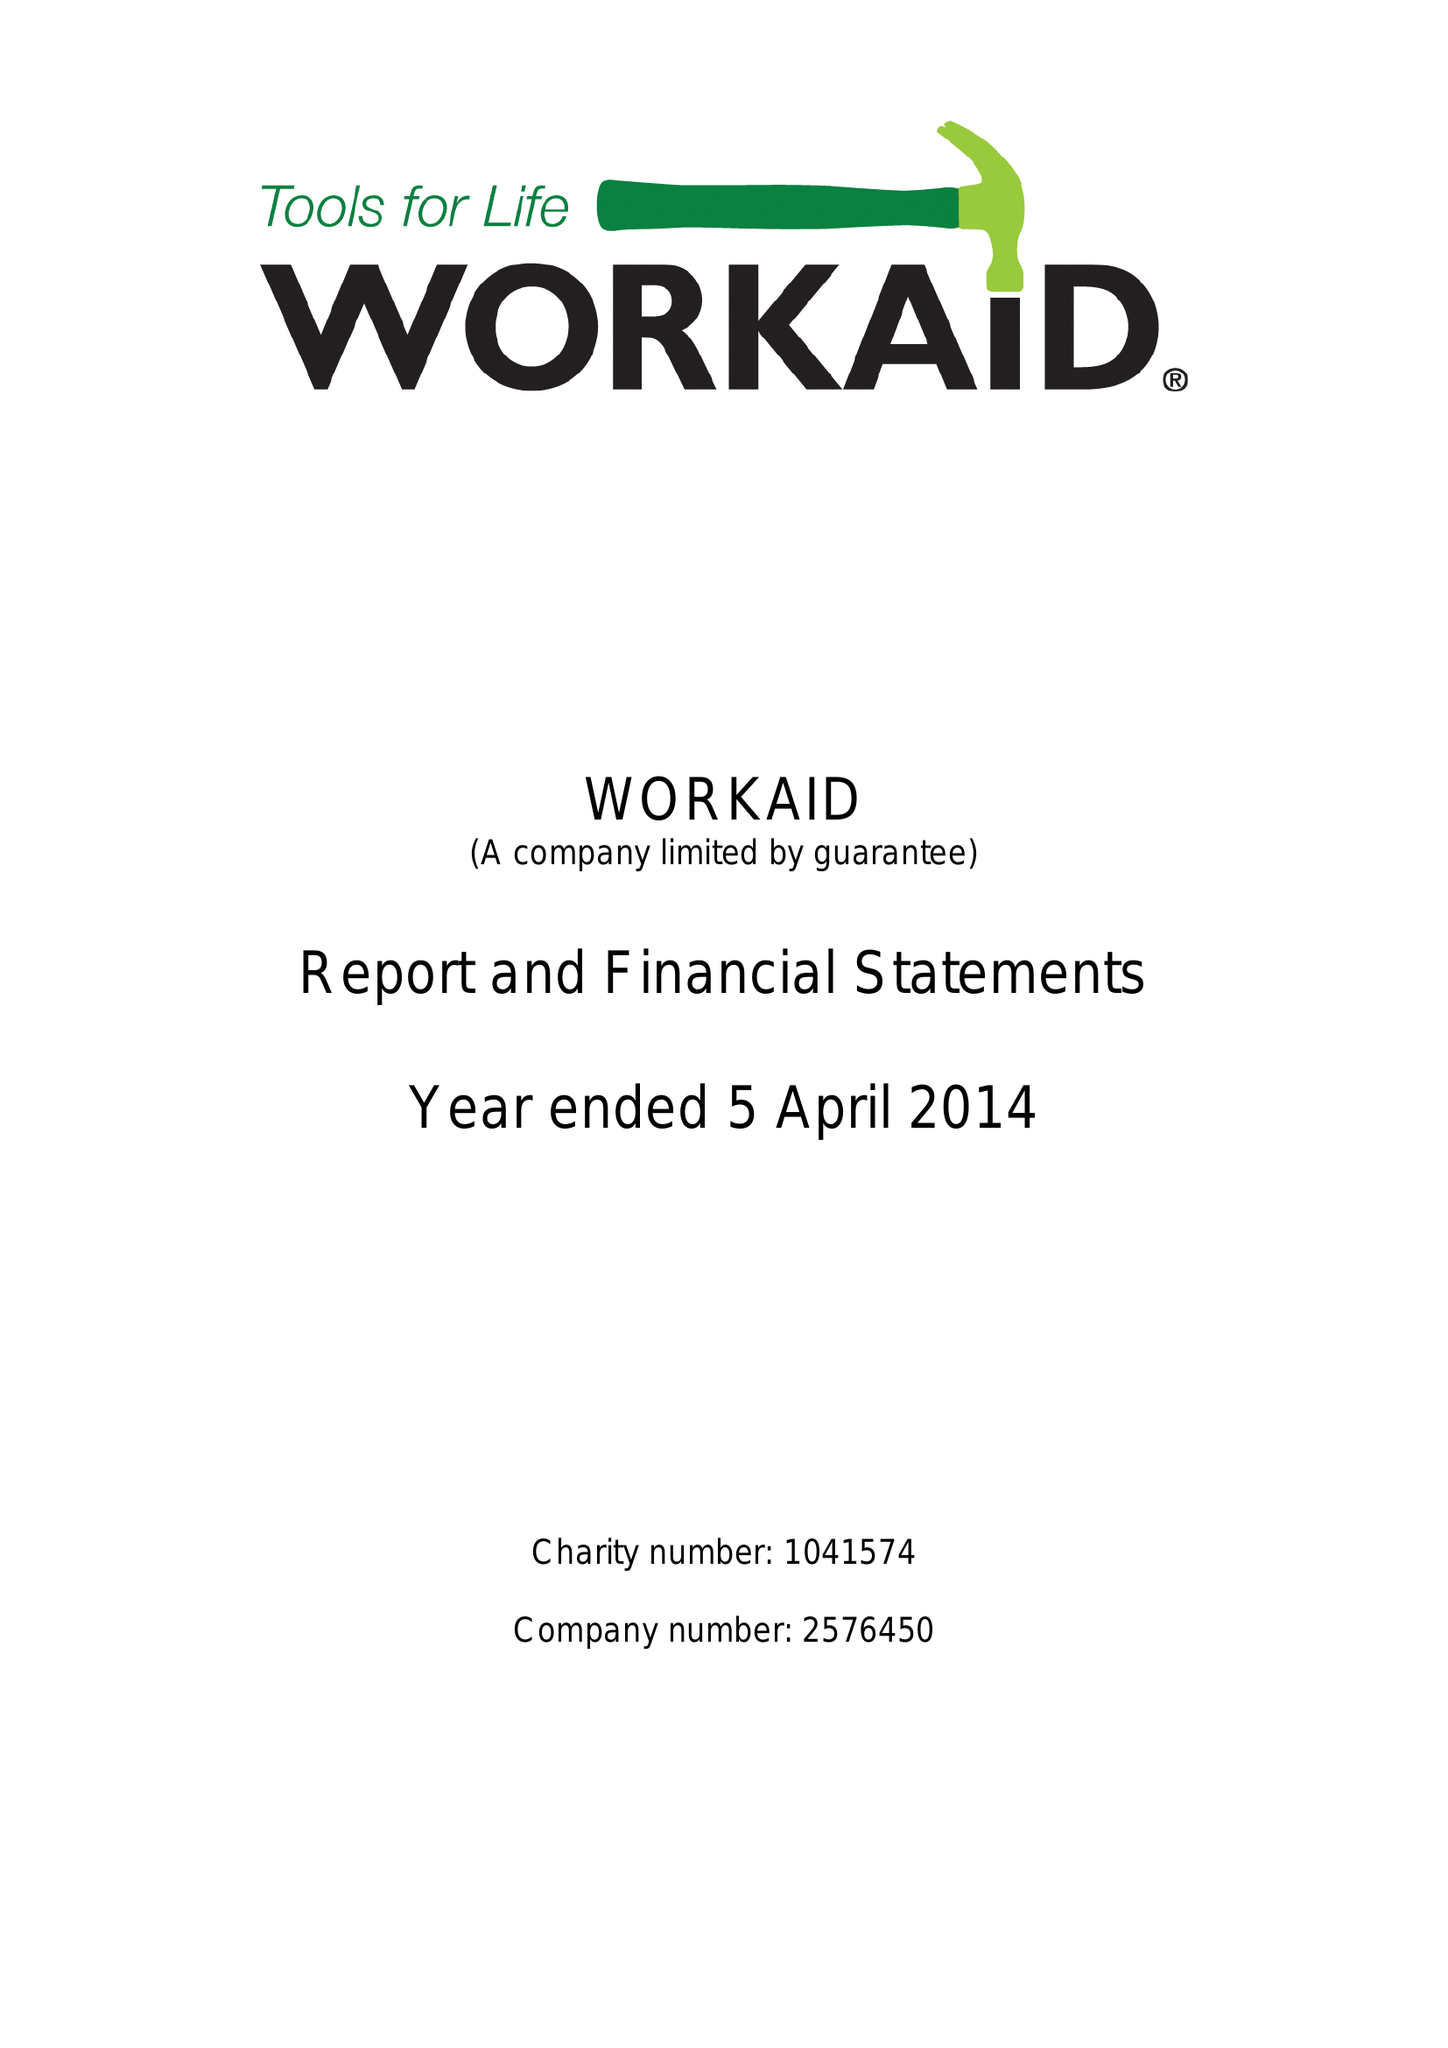What is the value for the spending_annually_in_british_pounds?
Answer the question using a single word or phrase. 206522.00 